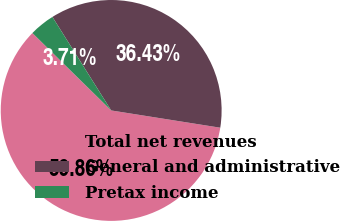Convert chart. <chart><loc_0><loc_0><loc_500><loc_500><pie_chart><fcel>Total net revenues<fcel>General and administrative<fcel>Pretax income<nl><fcel>59.86%<fcel>36.43%<fcel>3.71%<nl></chart> 